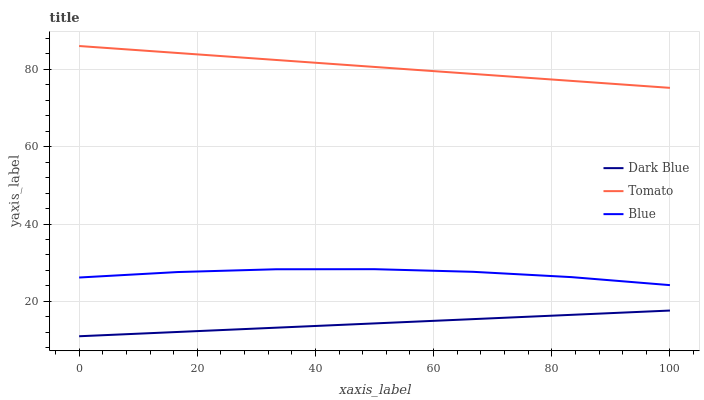Does Dark Blue have the minimum area under the curve?
Answer yes or no. Yes. Does Tomato have the maximum area under the curve?
Answer yes or no. Yes. Does Blue have the minimum area under the curve?
Answer yes or no. No. Does Blue have the maximum area under the curve?
Answer yes or no. No. Is Dark Blue the smoothest?
Answer yes or no. Yes. Is Blue the roughest?
Answer yes or no. Yes. Is Blue the smoothest?
Answer yes or no. No. Is Dark Blue the roughest?
Answer yes or no. No. Does Dark Blue have the lowest value?
Answer yes or no. Yes. Does Blue have the lowest value?
Answer yes or no. No. Does Tomato have the highest value?
Answer yes or no. Yes. Does Blue have the highest value?
Answer yes or no. No. Is Dark Blue less than Tomato?
Answer yes or no. Yes. Is Tomato greater than Blue?
Answer yes or no. Yes. Does Dark Blue intersect Tomato?
Answer yes or no. No. 